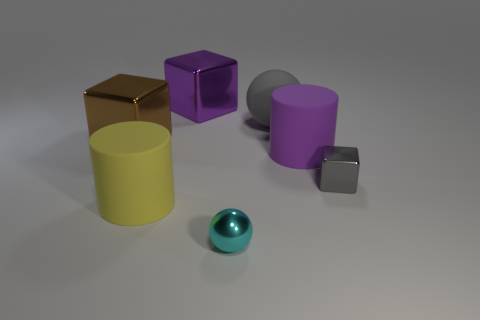What number of things are either small metal balls or purple objects in front of the rubber sphere?
Your answer should be very brief. 2. What material is the yellow object?
Give a very brief answer. Rubber. What material is the tiny cyan object that is the same shape as the big gray thing?
Provide a succinct answer. Metal. What color is the tiny object behind the rubber cylinder on the left side of the purple block?
Provide a short and direct response. Gray. What number of shiny things are either big yellow things or gray objects?
Provide a short and direct response. 1. Is the big purple cylinder made of the same material as the small cube?
Give a very brief answer. No. What is the big cube that is right of the large block on the left side of the purple cube made of?
Your answer should be very brief. Metal. What number of big things are either cyan objects or brown metallic things?
Your response must be concise. 1. What is the size of the yellow cylinder?
Give a very brief answer. Large. Are there more big cylinders in front of the small cyan ball than purple cubes?
Keep it short and to the point. No. 